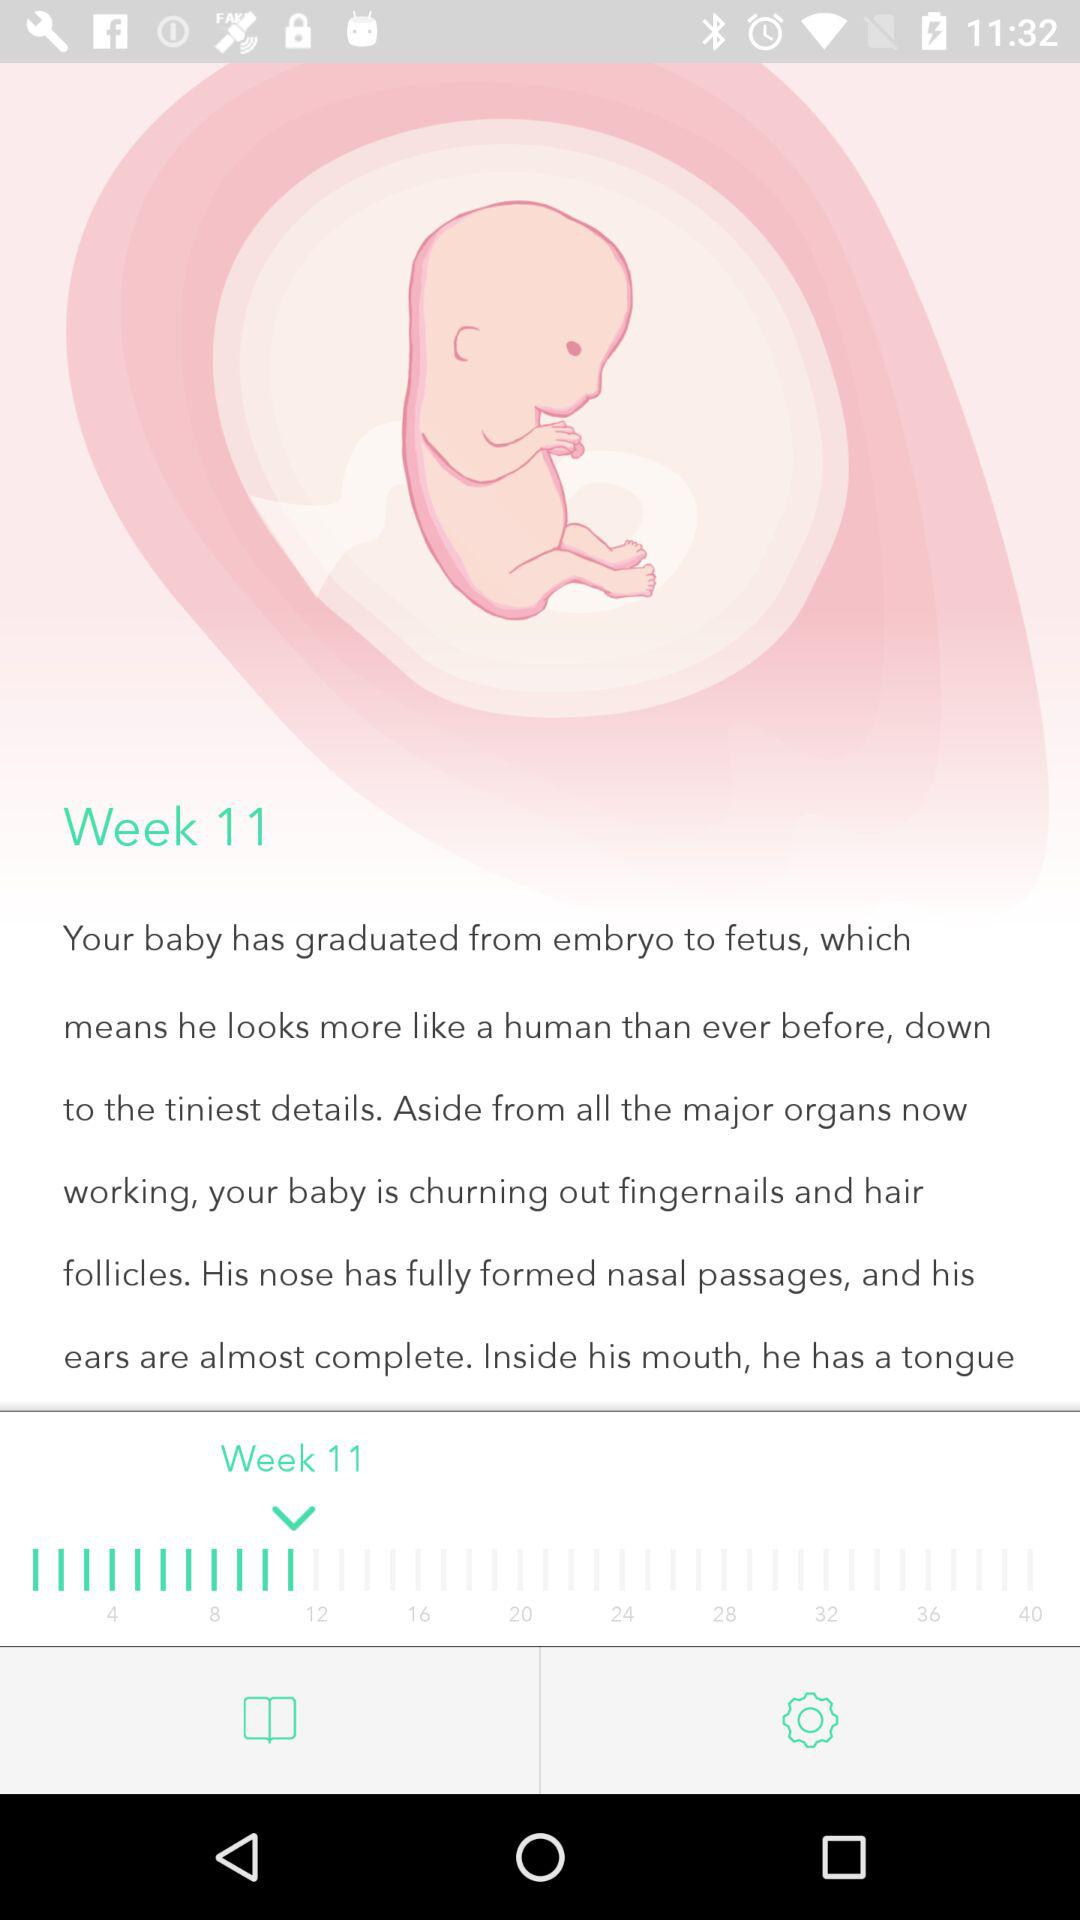How many weeks are there between the text '4' and the text '24'?
Answer the question using a single word or phrase. 20 